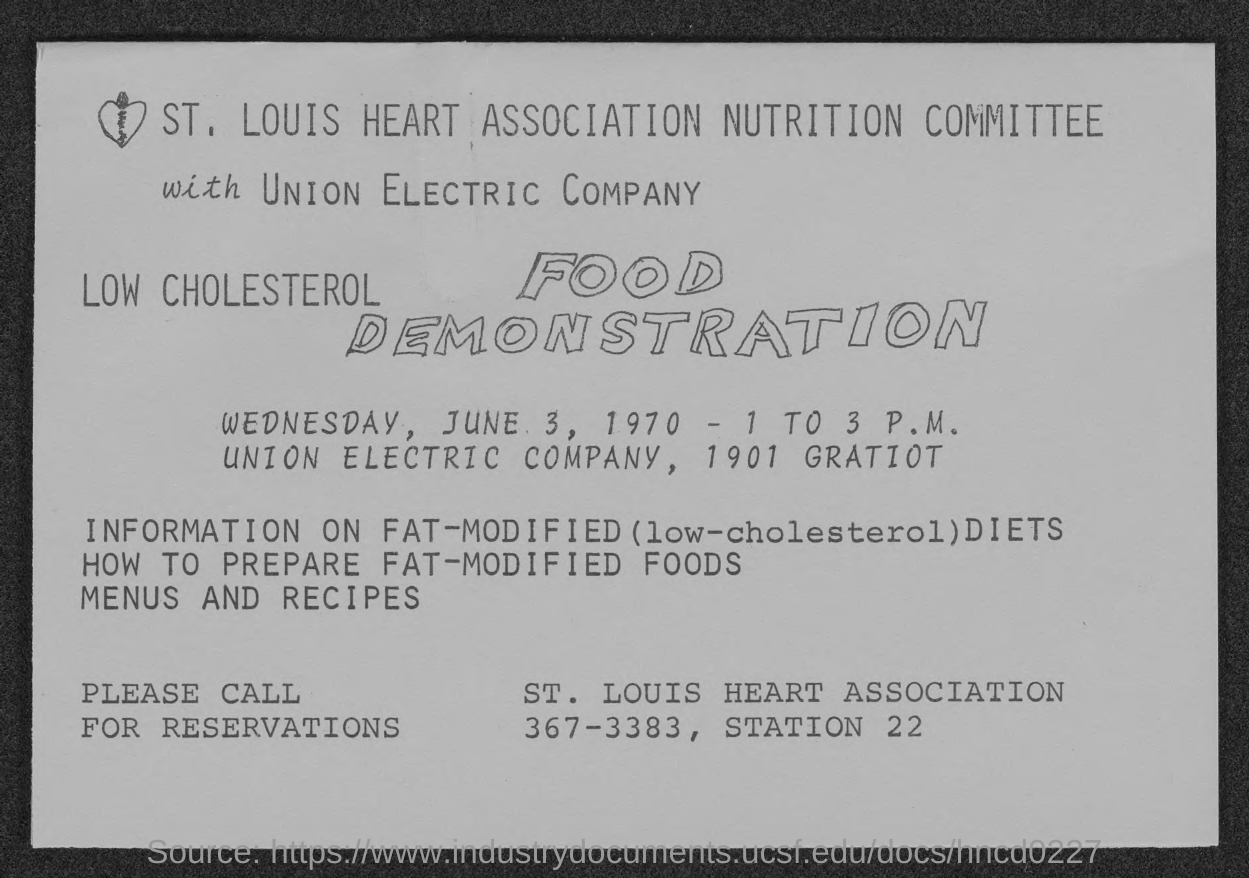What is the name of nutrition committee?
Offer a very short reply. St. Louis Heart association Nutrition Committee. What is the name of electric company?
Ensure brevity in your answer.  Union Electric Company. What is the contact number of st. louis heart association?
Keep it short and to the point. 367-3383. What is the street address of union electric company?
Give a very brief answer. 1901 Gratiot. 